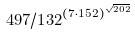Convert formula to latex. <formula><loc_0><loc_0><loc_500><loc_500>4 9 7 / 1 3 2 ^ { ( 7 \cdot 1 5 2 ) ^ { \sqrt { 2 0 2 } } }</formula> 